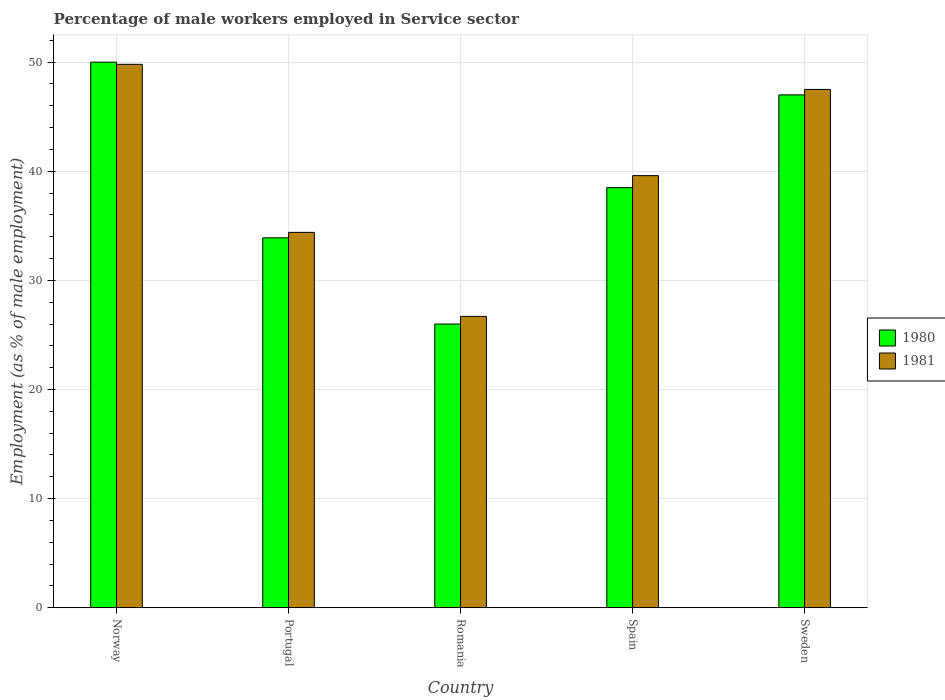How many different coloured bars are there?
Provide a short and direct response. 2. How many groups of bars are there?
Your answer should be compact. 5. Are the number of bars on each tick of the X-axis equal?
Keep it short and to the point. Yes. How many bars are there on the 3rd tick from the left?
Offer a very short reply. 2. How many bars are there on the 2nd tick from the right?
Your answer should be compact. 2. What is the percentage of male workers employed in Service sector in 1981 in Portugal?
Your answer should be very brief. 34.4. Across all countries, what is the maximum percentage of male workers employed in Service sector in 1980?
Offer a terse response. 50. Across all countries, what is the minimum percentage of male workers employed in Service sector in 1981?
Provide a short and direct response. 26.7. In which country was the percentage of male workers employed in Service sector in 1981 minimum?
Ensure brevity in your answer.  Romania. What is the total percentage of male workers employed in Service sector in 1981 in the graph?
Provide a short and direct response. 198. What is the difference between the percentage of male workers employed in Service sector in 1981 in Norway and that in Romania?
Your answer should be compact. 23.1. What is the difference between the percentage of male workers employed in Service sector in 1981 in Portugal and the percentage of male workers employed in Service sector in 1980 in Norway?
Give a very brief answer. -15.6. What is the average percentage of male workers employed in Service sector in 1980 per country?
Give a very brief answer. 39.08. What is the difference between the percentage of male workers employed in Service sector of/in 1981 and percentage of male workers employed in Service sector of/in 1980 in Spain?
Your answer should be compact. 1.1. What is the ratio of the percentage of male workers employed in Service sector in 1980 in Portugal to that in Sweden?
Keep it short and to the point. 0.72. Is the percentage of male workers employed in Service sector in 1981 in Portugal less than that in Spain?
Provide a short and direct response. Yes. What is the difference between the highest and the lowest percentage of male workers employed in Service sector in 1981?
Make the answer very short. 23.1. In how many countries, is the percentage of male workers employed in Service sector in 1981 greater than the average percentage of male workers employed in Service sector in 1981 taken over all countries?
Your response must be concise. 2. What does the 1st bar from the left in Norway represents?
Offer a very short reply. 1980. What does the 2nd bar from the right in Romania represents?
Make the answer very short. 1980. Are all the bars in the graph horizontal?
Provide a short and direct response. No. How many countries are there in the graph?
Keep it short and to the point. 5. What is the difference between two consecutive major ticks on the Y-axis?
Offer a terse response. 10. Does the graph contain any zero values?
Keep it short and to the point. No. Does the graph contain grids?
Ensure brevity in your answer.  Yes. Where does the legend appear in the graph?
Provide a succinct answer. Center right. How are the legend labels stacked?
Make the answer very short. Vertical. What is the title of the graph?
Make the answer very short. Percentage of male workers employed in Service sector. Does "1970" appear as one of the legend labels in the graph?
Offer a terse response. No. What is the label or title of the X-axis?
Your response must be concise. Country. What is the label or title of the Y-axis?
Your answer should be very brief. Employment (as % of male employment). What is the Employment (as % of male employment) of 1981 in Norway?
Your answer should be very brief. 49.8. What is the Employment (as % of male employment) in 1980 in Portugal?
Offer a terse response. 33.9. What is the Employment (as % of male employment) in 1981 in Portugal?
Your response must be concise. 34.4. What is the Employment (as % of male employment) of 1980 in Romania?
Give a very brief answer. 26. What is the Employment (as % of male employment) of 1981 in Romania?
Give a very brief answer. 26.7. What is the Employment (as % of male employment) in 1980 in Spain?
Keep it short and to the point. 38.5. What is the Employment (as % of male employment) in 1981 in Spain?
Make the answer very short. 39.6. What is the Employment (as % of male employment) of 1981 in Sweden?
Offer a terse response. 47.5. Across all countries, what is the maximum Employment (as % of male employment) of 1981?
Your response must be concise. 49.8. Across all countries, what is the minimum Employment (as % of male employment) in 1980?
Provide a short and direct response. 26. Across all countries, what is the minimum Employment (as % of male employment) of 1981?
Give a very brief answer. 26.7. What is the total Employment (as % of male employment) of 1980 in the graph?
Keep it short and to the point. 195.4. What is the total Employment (as % of male employment) in 1981 in the graph?
Ensure brevity in your answer.  198. What is the difference between the Employment (as % of male employment) of 1980 in Norway and that in Romania?
Keep it short and to the point. 24. What is the difference between the Employment (as % of male employment) of 1981 in Norway and that in Romania?
Give a very brief answer. 23.1. What is the difference between the Employment (as % of male employment) of 1980 in Norway and that in Spain?
Give a very brief answer. 11.5. What is the difference between the Employment (as % of male employment) of 1981 in Norway and that in Spain?
Keep it short and to the point. 10.2. What is the difference between the Employment (as % of male employment) of 1981 in Norway and that in Sweden?
Offer a terse response. 2.3. What is the difference between the Employment (as % of male employment) in 1980 in Portugal and that in Romania?
Provide a succinct answer. 7.9. What is the difference between the Employment (as % of male employment) in 1980 in Portugal and that in Spain?
Your response must be concise. -4.6. What is the difference between the Employment (as % of male employment) of 1981 in Portugal and that in Spain?
Make the answer very short. -5.2. What is the difference between the Employment (as % of male employment) in 1981 in Portugal and that in Sweden?
Make the answer very short. -13.1. What is the difference between the Employment (as % of male employment) of 1981 in Romania and that in Spain?
Give a very brief answer. -12.9. What is the difference between the Employment (as % of male employment) in 1981 in Romania and that in Sweden?
Give a very brief answer. -20.8. What is the difference between the Employment (as % of male employment) of 1981 in Spain and that in Sweden?
Make the answer very short. -7.9. What is the difference between the Employment (as % of male employment) of 1980 in Norway and the Employment (as % of male employment) of 1981 in Portugal?
Your answer should be compact. 15.6. What is the difference between the Employment (as % of male employment) in 1980 in Norway and the Employment (as % of male employment) in 1981 in Romania?
Keep it short and to the point. 23.3. What is the difference between the Employment (as % of male employment) in 1980 in Norway and the Employment (as % of male employment) in 1981 in Spain?
Offer a very short reply. 10.4. What is the difference between the Employment (as % of male employment) of 1980 in Portugal and the Employment (as % of male employment) of 1981 in Sweden?
Offer a terse response. -13.6. What is the difference between the Employment (as % of male employment) in 1980 in Romania and the Employment (as % of male employment) in 1981 in Sweden?
Make the answer very short. -21.5. What is the average Employment (as % of male employment) in 1980 per country?
Keep it short and to the point. 39.08. What is the average Employment (as % of male employment) of 1981 per country?
Your response must be concise. 39.6. What is the difference between the Employment (as % of male employment) of 1980 and Employment (as % of male employment) of 1981 in Portugal?
Offer a very short reply. -0.5. What is the difference between the Employment (as % of male employment) in 1980 and Employment (as % of male employment) in 1981 in Romania?
Provide a succinct answer. -0.7. What is the difference between the Employment (as % of male employment) of 1980 and Employment (as % of male employment) of 1981 in Sweden?
Give a very brief answer. -0.5. What is the ratio of the Employment (as % of male employment) of 1980 in Norway to that in Portugal?
Your answer should be compact. 1.47. What is the ratio of the Employment (as % of male employment) in 1981 in Norway to that in Portugal?
Ensure brevity in your answer.  1.45. What is the ratio of the Employment (as % of male employment) in 1980 in Norway to that in Romania?
Offer a terse response. 1.92. What is the ratio of the Employment (as % of male employment) in 1981 in Norway to that in Romania?
Make the answer very short. 1.87. What is the ratio of the Employment (as % of male employment) in 1980 in Norway to that in Spain?
Provide a short and direct response. 1.3. What is the ratio of the Employment (as % of male employment) in 1981 in Norway to that in Spain?
Give a very brief answer. 1.26. What is the ratio of the Employment (as % of male employment) in 1980 in Norway to that in Sweden?
Offer a very short reply. 1.06. What is the ratio of the Employment (as % of male employment) in 1981 in Norway to that in Sweden?
Your answer should be compact. 1.05. What is the ratio of the Employment (as % of male employment) of 1980 in Portugal to that in Romania?
Ensure brevity in your answer.  1.3. What is the ratio of the Employment (as % of male employment) in 1981 in Portugal to that in Romania?
Your response must be concise. 1.29. What is the ratio of the Employment (as % of male employment) of 1980 in Portugal to that in Spain?
Give a very brief answer. 0.88. What is the ratio of the Employment (as % of male employment) of 1981 in Portugal to that in Spain?
Your answer should be very brief. 0.87. What is the ratio of the Employment (as % of male employment) in 1980 in Portugal to that in Sweden?
Give a very brief answer. 0.72. What is the ratio of the Employment (as % of male employment) in 1981 in Portugal to that in Sweden?
Offer a very short reply. 0.72. What is the ratio of the Employment (as % of male employment) in 1980 in Romania to that in Spain?
Ensure brevity in your answer.  0.68. What is the ratio of the Employment (as % of male employment) of 1981 in Romania to that in Spain?
Ensure brevity in your answer.  0.67. What is the ratio of the Employment (as % of male employment) of 1980 in Romania to that in Sweden?
Provide a succinct answer. 0.55. What is the ratio of the Employment (as % of male employment) of 1981 in Romania to that in Sweden?
Offer a terse response. 0.56. What is the ratio of the Employment (as % of male employment) in 1980 in Spain to that in Sweden?
Offer a terse response. 0.82. What is the ratio of the Employment (as % of male employment) of 1981 in Spain to that in Sweden?
Your response must be concise. 0.83. What is the difference between the highest and the second highest Employment (as % of male employment) in 1981?
Provide a short and direct response. 2.3. What is the difference between the highest and the lowest Employment (as % of male employment) in 1980?
Offer a very short reply. 24. What is the difference between the highest and the lowest Employment (as % of male employment) in 1981?
Your response must be concise. 23.1. 